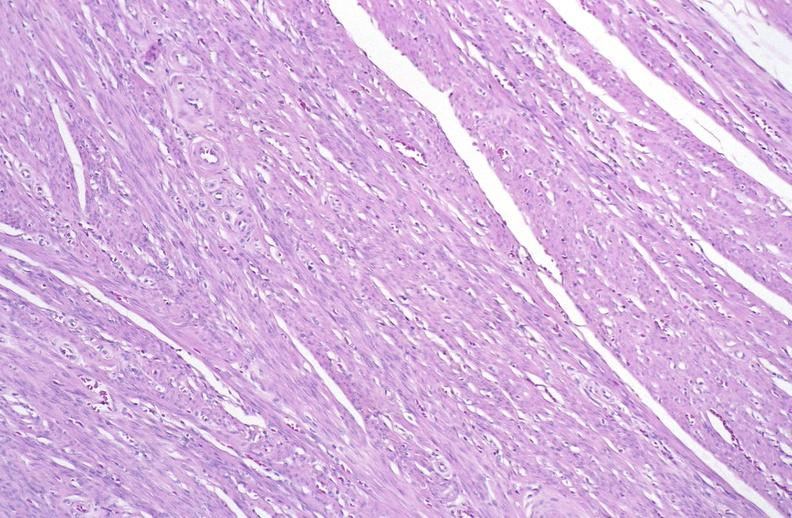where is this from?
Answer the question using a single word or phrase. Female reproductive system 